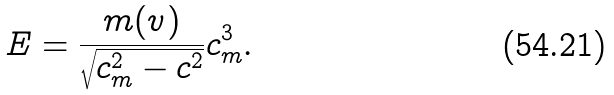<formula> <loc_0><loc_0><loc_500><loc_500>E = \frac { m ( v ) } { \sqrt { c _ { m } ^ { 2 } - c ^ { 2 } } } c _ { m } ^ { 3 } .</formula> 